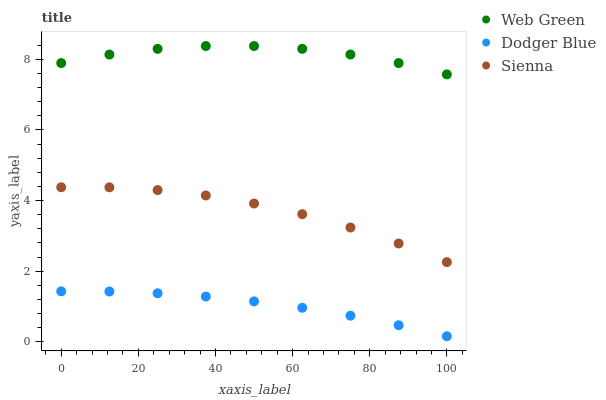Does Dodger Blue have the minimum area under the curve?
Answer yes or no. Yes. Does Web Green have the maximum area under the curve?
Answer yes or no. Yes. Does Web Green have the minimum area under the curve?
Answer yes or no. No. Does Dodger Blue have the maximum area under the curve?
Answer yes or no. No. Is Dodger Blue the smoothest?
Answer yes or no. Yes. Is Web Green the roughest?
Answer yes or no. Yes. Is Web Green the smoothest?
Answer yes or no. No. Is Dodger Blue the roughest?
Answer yes or no. No. Does Dodger Blue have the lowest value?
Answer yes or no. Yes. Does Web Green have the lowest value?
Answer yes or no. No. Does Web Green have the highest value?
Answer yes or no. Yes. Does Dodger Blue have the highest value?
Answer yes or no. No. Is Sienna less than Web Green?
Answer yes or no. Yes. Is Web Green greater than Sienna?
Answer yes or no. Yes. Does Sienna intersect Web Green?
Answer yes or no. No. 